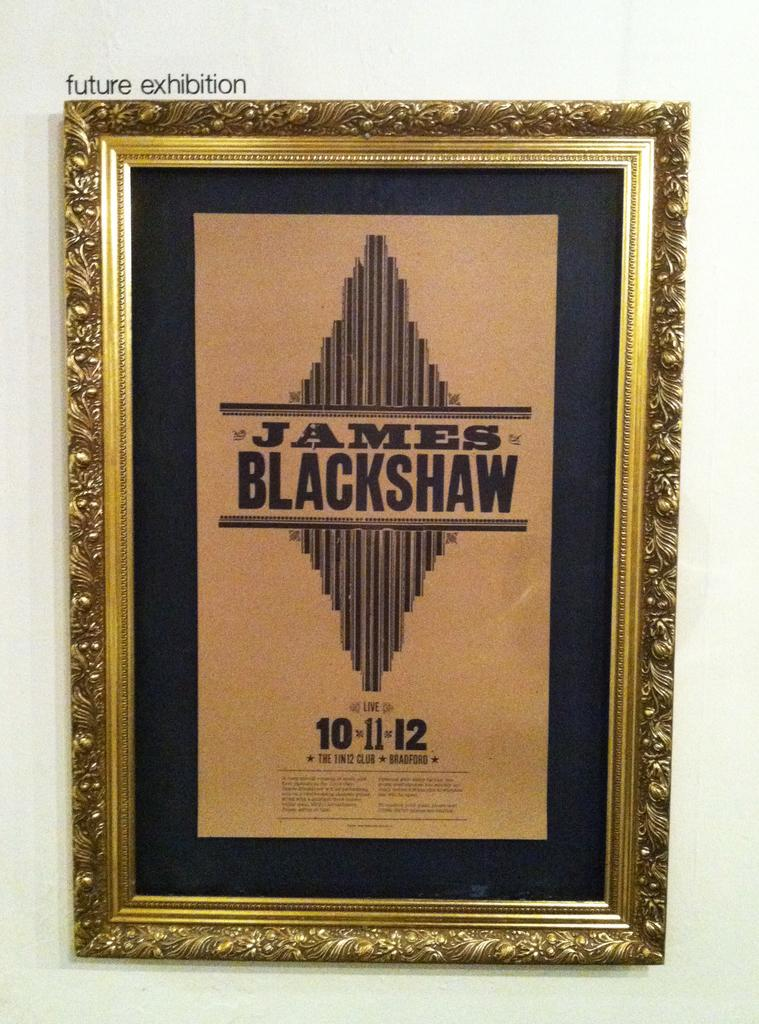<image>
Provide a brief description of the given image. A decorative gold frame with a poster in the center that says James Blackshaw and the date 10.11.12. 